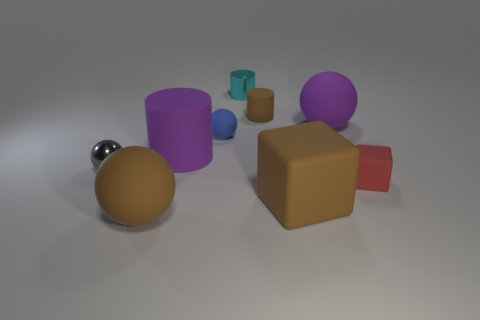What could be the context or function of these objects? The objects seem to be simple 3D models, likely placed in this setting for visualization or instructional purposes. They could serve as examples in a computer graphics demonstration, teaching about shapes, materials, lighting, and rendering techniques. 